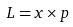Convert formula to latex. <formula><loc_0><loc_0><loc_500><loc_500>L = x \times p</formula> 